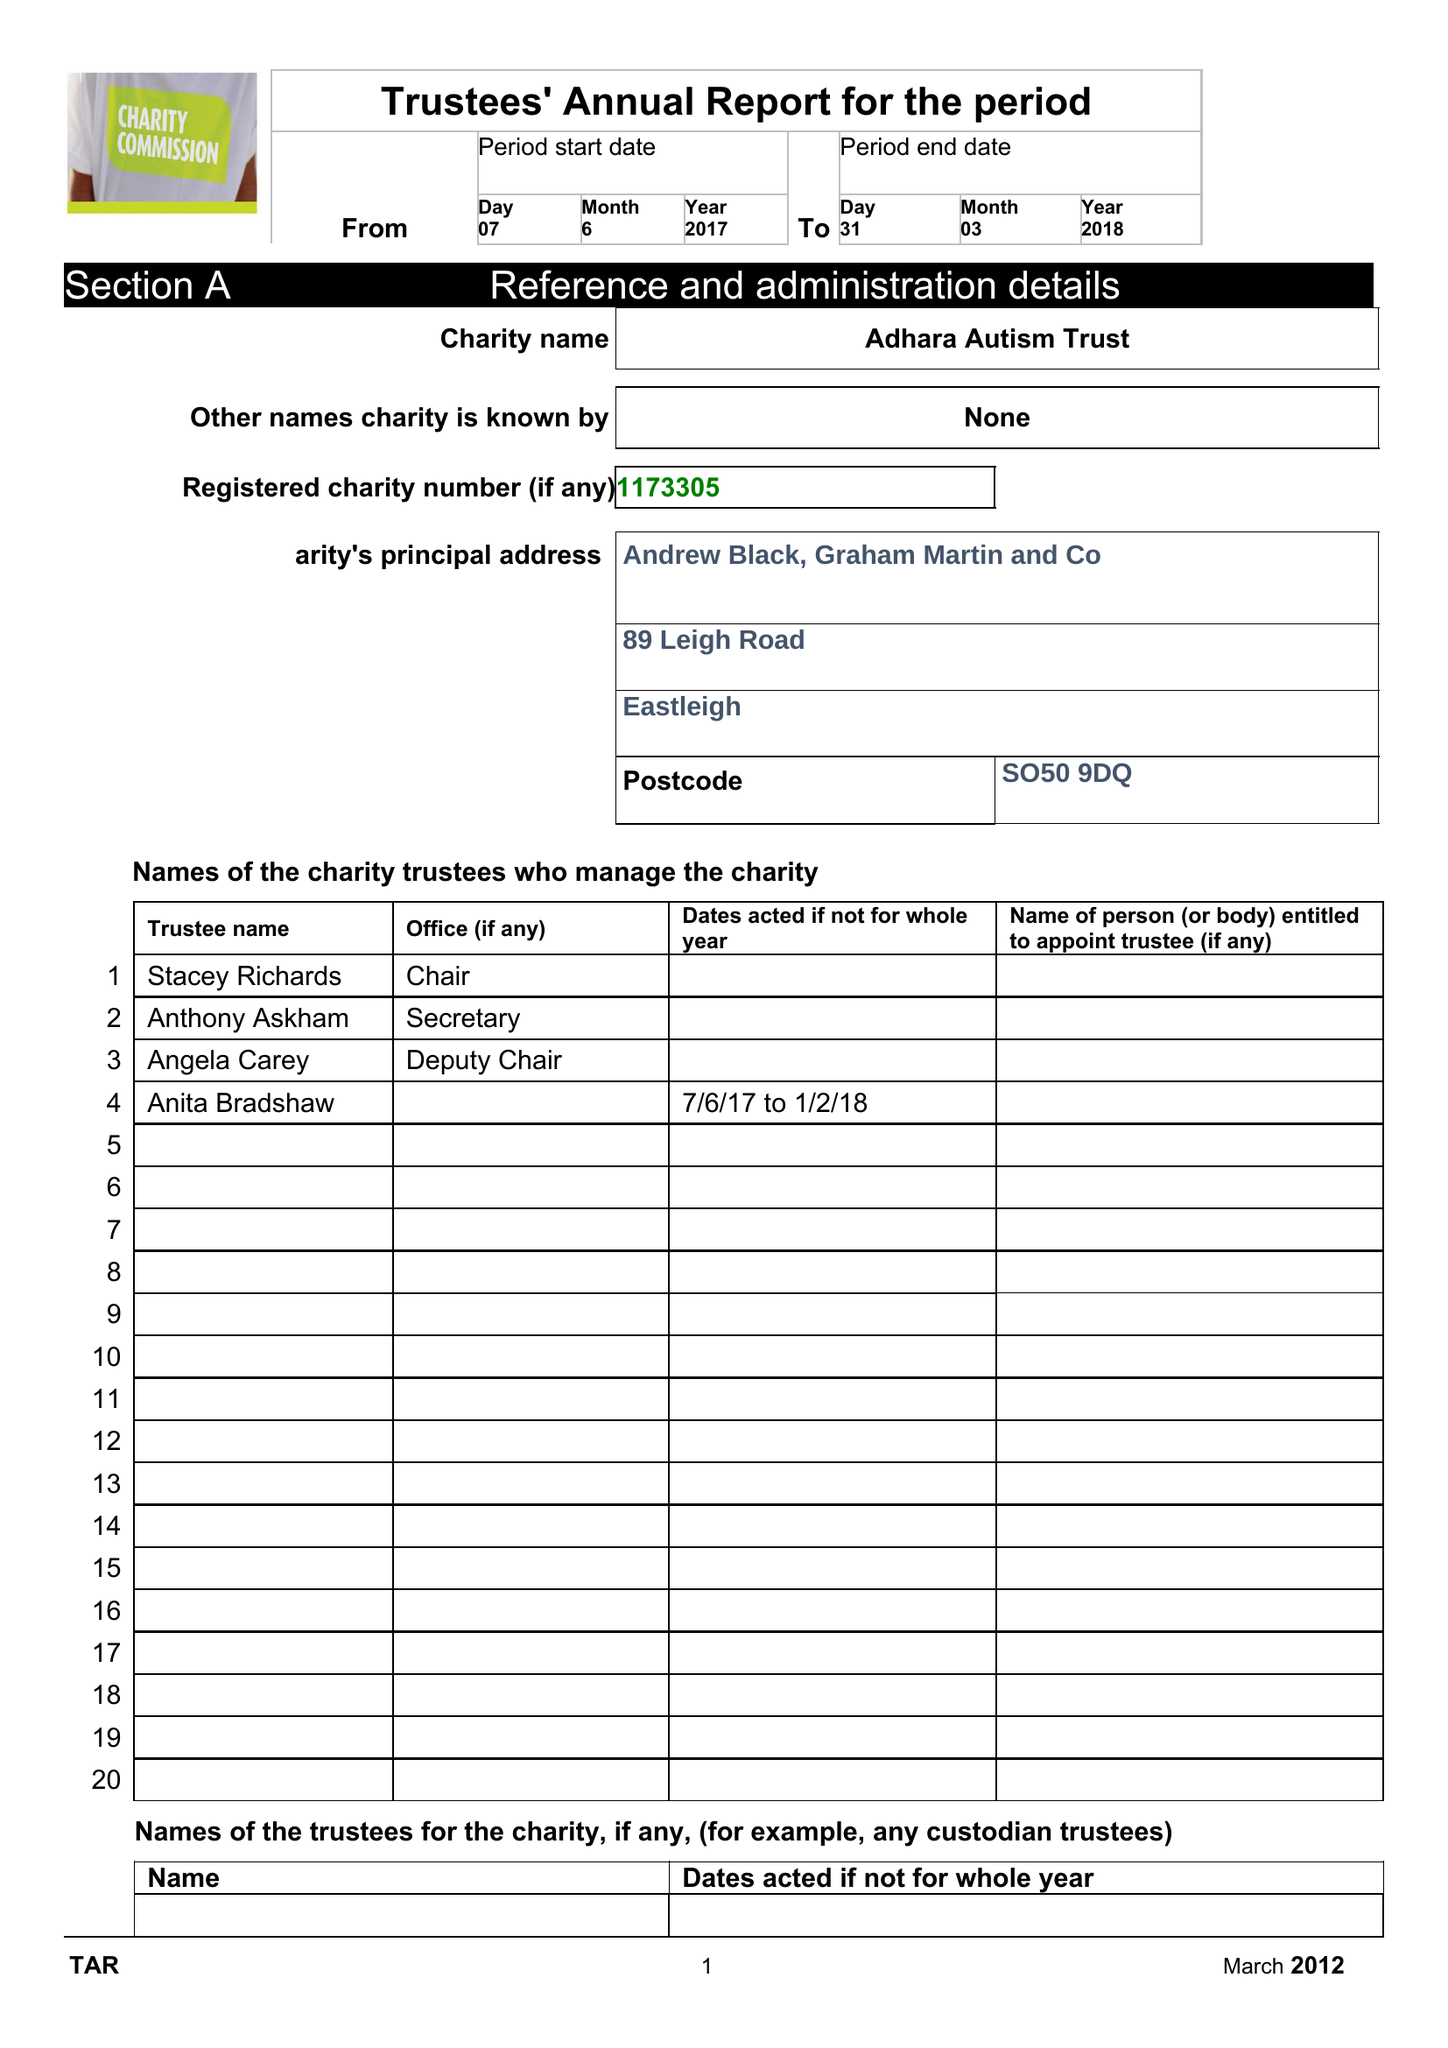What is the value for the address__postcode?
Answer the question using a single word or phrase. SO50 9DQ 